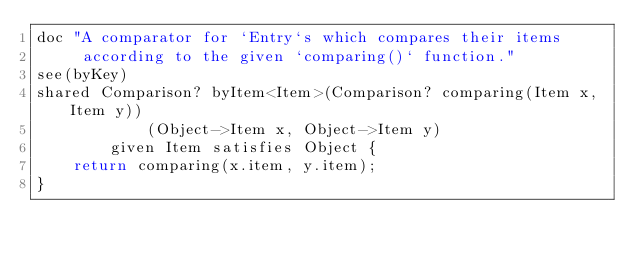<code> <loc_0><loc_0><loc_500><loc_500><_Ceylon_>doc "A comparator for `Entry`s which compares their items 
     according to the given `comparing()` function."
see(byKey)
shared Comparison? byItem<Item>(Comparison? comparing(Item x, Item y))
            (Object->Item x, Object->Item y) 
        given Item satisfies Object {
    return comparing(x.item, y.item);
}</code> 